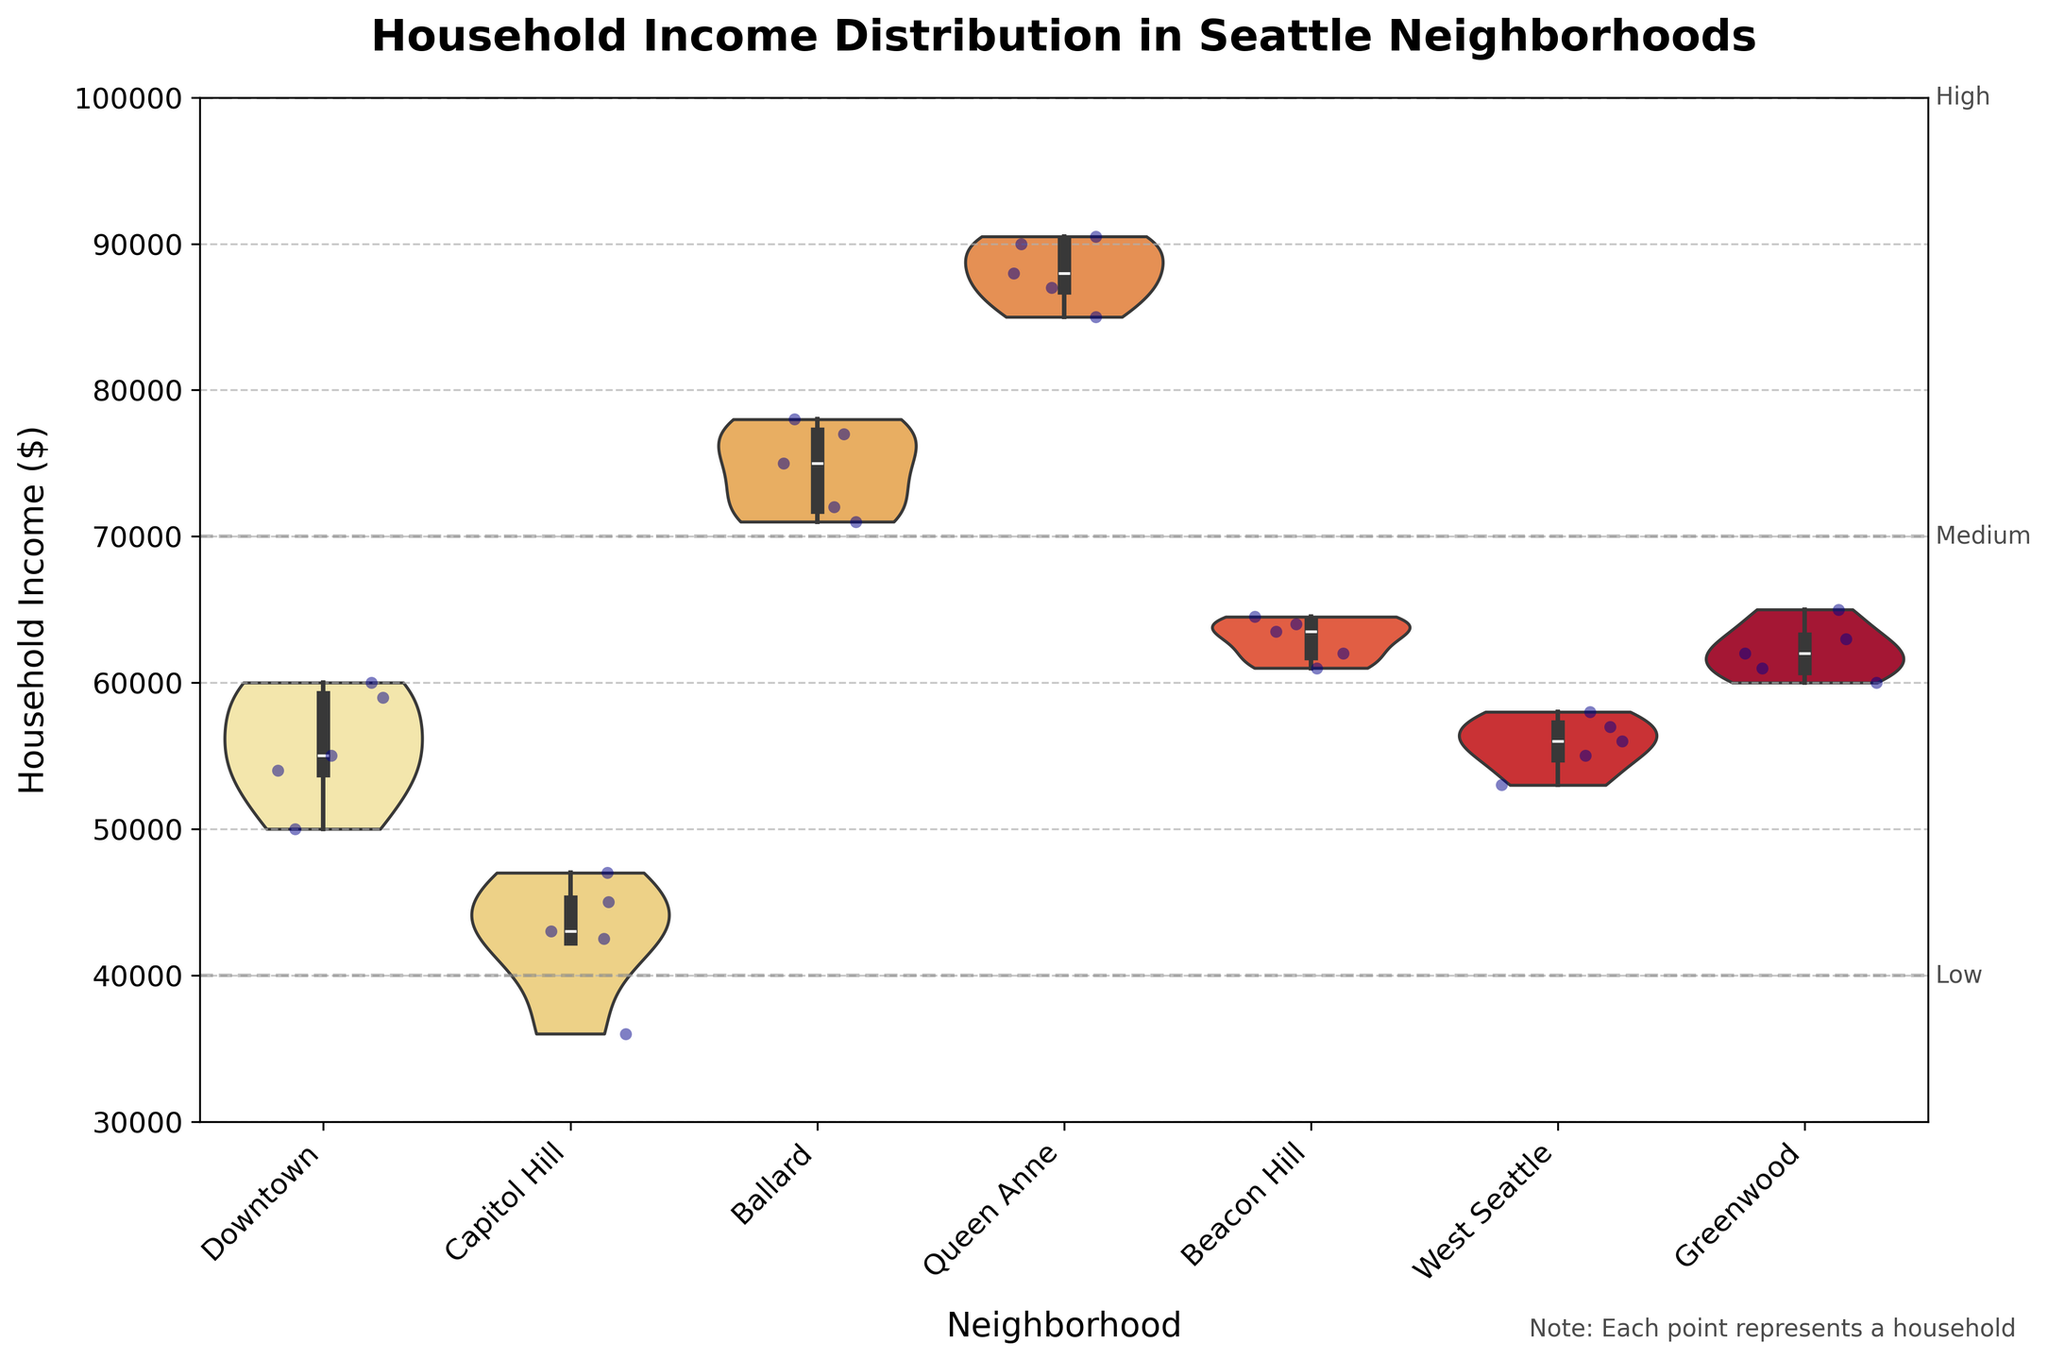What is the title of the plot? The title of the plot is usually found at the top of the figure and is written in larger, bold text. Here, it reads "Household Income Distribution in Seattle Neighborhoods".
Answer: Household Income Distribution in Seattle Neighborhoods Which neighborhood has the highest median household income according to the plot? We can determine the median household income by looking at the center of the box inside each violin shape. For Queen Anne, the box center is the highest among all neighborhoods.
Answer: Queen Anne What's the range of household income represented in Capitol Hill? The range is the difference between the maximum and minimum values within the Capitol Hill section. The top of the violin plot for Capitol Hill shows the highest value around $47000, and the bottom shows the lowest value around $36000. Therefore, the range is $47000 - $36000 = $11000.
Answer: $11000 How do the household incomes in Ballard compare to those in Greenwood? To compare, we look at both the spread and the central tendencies like median and quartiles within each violin shape. Ballard has a higher median and higher overall income spread compared to Greenwood, suggesting generally higher household incomes.
Answer: Ballard has higher incomes Which neighborhood has the most variability in household income? Variability is indicated by the width and spread of the violin plot. Queen Anne has the widest and most spread-out violin shape, indicating the largest variability.
Answer: Queen Anne What's the lower limit of the ‘High’ income bracket provided in the plot? The plot shows horizontal lines with annotations indicating income brackets. The 'High' income bracket starts from $70000 and goes upwards.
Answer: $70000 Are there any neighborhoods with household incomes falling below $40,000? We need to look below the $40,000 line in each violin plot. Capitol Hill is the only neighborhood with data points below $40,000.
Answer: Capitol Hill What's the approximate median household income in Beacon Hill? The median is represented by the center of the box plot inside the violin shape. For Beacon Hill, this point is close to $63000.
Answer: $63000 Does West Seattle have incomes that fall into the 'Low' bracket? The 'Low' bracket is below $40000. In West Seattle, there are no points or distribution below this value, indicating there are no 'Low' bracket incomes.
Answer: No How do the distributions of household incomes in Downtown and Capitol Hill compare? We compare the shapes of the violin plots and positions of the medians. Downtown has a higher median and is more tightly distributed between $50000 and $60000, while Capitol Hill has a lower median and is more spread out with values extending down to around $36000.
Answer: Downtown has higher and less spread incomes than Capitol Hill 